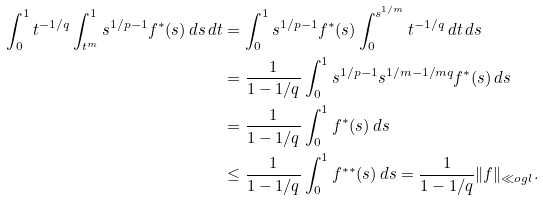Convert formula to latex. <formula><loc_0><loc_0><loc_500><loc_500>\int _ { 0 } ^ { 1 } t ^ { - 1 / q } \int _ { t ^ { m } } ^ { 1 } s ^ { 1 / p - 1 } f ^ { * } ( s ) \, d s \, d t & = \int _ { 0 } ^ { 1 } s ^ { 1 / p - 1 } f ^ { * } ( s ) \int _ { 0 } ^ { s ^ { 1 / m } } t ^ { - 1 / q } \, d t \, d s \\ & = \frac { 1 } { 1 - 1 / q } \int _ { 0 } ^ { 1 } s ^ { 1 / p - 1 } s ^ { 1 / m - 1 / m q } f ^ { * } ( s ) \, d s \\ & = \frac { 1 } { 1 - 1 / q } \int _ { 0 } ^ { 1 } f ^ { * } ( s ) \, d s \\ & \leq \frac { 1 } { 1 - 1 / q } \int _ { 0 } ^ { 1 } f ^ { * * } ( s ) \, d s = \frac { 1 } { 1 - 1 / q } \| f \| _ { \ll o g l } .</formula> 